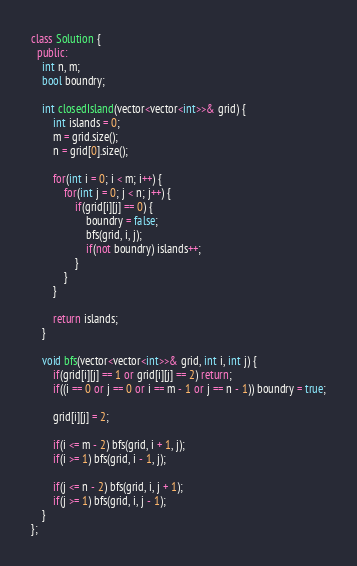<code> <loc_0><loc_0><loc_500><loc_500><_C++_>class Solution {
  public:
	int n, m;
	bool boundry;

	int closedIsland(vector<vector<int>>& grid) {
		int islands = 0;
		m = grid.size();
		n = grid[0].size();

		for(int i = 0; i < m; i++) {
			for(int j = 0; j < n; j++) {
				if(grid[i][j] == 0) {
					boundry = false;
					bfs(grid, i, j);
					if(not boundry) islands++;
				}
			}
		}

		return islands;
	}

	void bfs(vector<vector<int>>& grid, int i, int j) {
		if(grid[i][j] == 1 or grid[i][j] == 2) return;
		if((i == 0 or j == 0 or i == m - 1 or j == n - 1)) boundry = true;

		grid[i][j] = 2;

		if(i <= m - 2) bfs(grid, i + 1, j);
		if(i >= 1) bfs(grid, i - 1, j);

		if(j <= n - 2) bfs(grid, i, j + 1);
		if(j >= 1) bfs(grid, i, j - 1);
	}
};</code> 